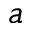<formula> <loc_0><loc_0><loc_500><loc_500>a</formula> 